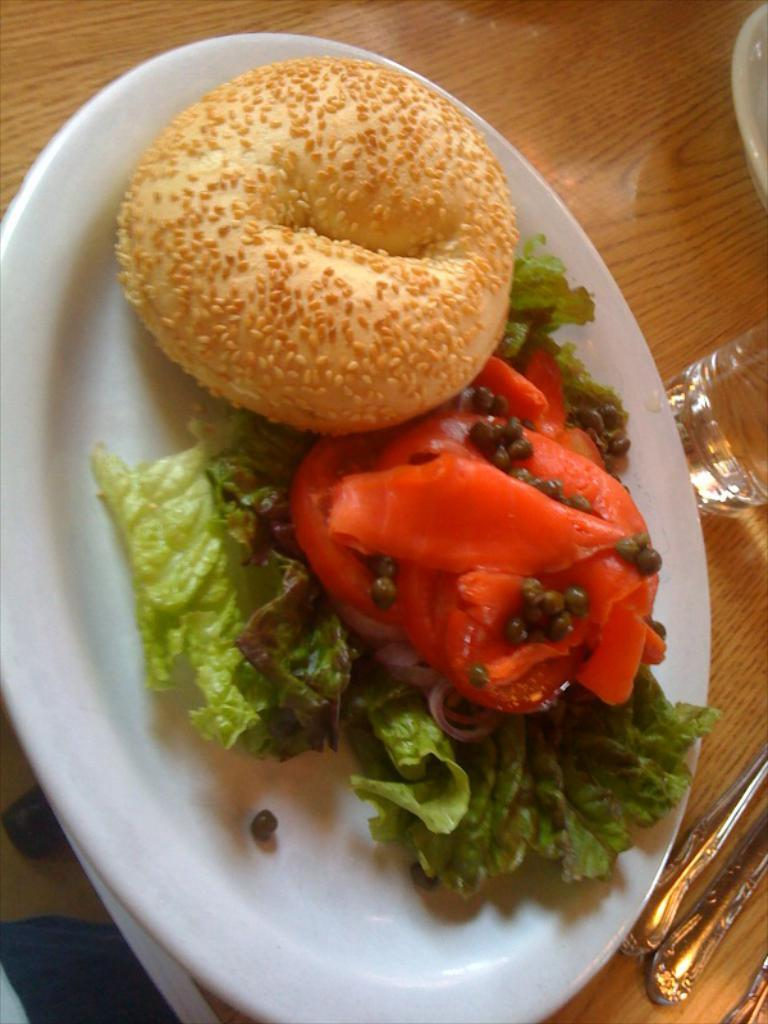What type of furniture is present in the image? There is a table in the image. What is placed on the table? There is a white color plate on the table, and there is food in the plate. What else can be seen on the table? There is a glass and spoons on the table. What year is depicted in the image? The image does not depict a specific year; it is a still image of a table setting. 